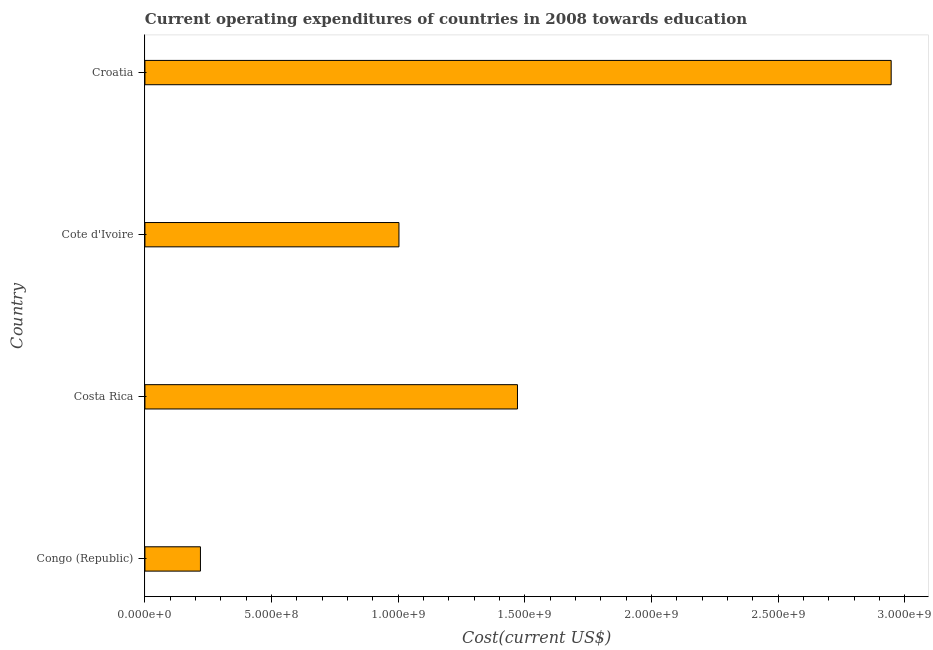Does the graph contain grids?
Offer a very short reply. No. What is the title of the graph?
Make the answer very short. Current operating expenditures of countries in 2008 towards education. What is the label or title of the X-axis?
Offer a terse response. Cost(current US$). What is the education expenditure in Croatia?
Your answer should be very brief. 2.95e+09. Across all countries, what is the maximum education expenditure?
Offer a very short reply. 2.95e+09. Across all countries, what is the minimum education expenditure?
Your answer should be very brief. 2.19e+08. In which country was the education expenditure maximum?
Provide a short and direct response. Croatia. In which country was the education expenditure minimum?
Keep it short and to the point. Congo (Republic). What is the sum of the education expenditure?
Offer a very short reply. 5.64e+09. What is the difference between the education expenditure in Congo (Republic) and Croatia?
Keep it short and to the point. -2.73e+09. What is the average education expenditure per country?
Keep it short and to the point. 1.41e+09. What is the median education expenditure?
Your answer should be compact. 1.24e+09. In how many countries, is the education expenditure greater than 500000000 US$?
Your response must be concise. 3. What is the ratio of the education expenditure in Congo (Republic) to that in Croatia?
Ensure brevity in your answer.  0.07. Is the difference between the education expenditure in Congo (Republic) and Croatia greater than the difference between any two countries?
Offer a very short reply. Yes. What is the difference between the highest and the second highest education expenditure?
Your answer should be very brief. 1.48e+09. What is the difference between the highest and the lowest education expenditure?
Offer a very short reply. 2.73e+09. How many countries are there in the graph?
Provide a succinct answer. 4. What is the difference between two consecutive major ticks on the X-axis?
Give a very brief answer. 5.00e+08. What is the Cost(current US$) of Congo (Republic)?
Keep it short and to the point. 2.19e+08. What is the Cost(current US$) in Costa Rica?
Provide a short and direct response. 1.47e+09. What is the Cost(current US$) in Cote d'Ivoire?
Your answer should be compact. 1.00e+09. What is the Cost(current US$) in Croatia?
Keep it short and to the point. 2.95e+09. What is the difference between the Cost(current US$) in Congo (Republic) and Costa Rica?
Ensure brevity in your answer.  -1.25e+09. What is the difference between the Cost(current US$) in Congo (Republic) and Cote d'Ivoire?
Make the answer very short. -7.84e+08. What is the difference between the Cost(current US$) in Congo (Republic) and Croatia?
Give a very brief answer. -2.73e+09. What is the difference between the Cost(current US$) in Costa Rica and Cote d'Ivoire?
Give a very brief answer. 4.68e+08. What is the difference between the Cost(current US$) in Costa Rica and Croatia?
Your answer should be very brief. -1.48e+09. What is the difference between the Cost(current US$) in Cote d'Ivoire and Croatia?
Your answer should be very brief. -1.94e+09. What is the ratio of the Cost(current US$) in Congo (Republic) to that in Costa Rica?
Provide a short and direct response. 0.15. What is the ratio of the Cost(current US$) in Congo (Republic) to that in Cote d'Ivoire?
Offer a terse response. 0.22. What is the ratio of the Cost(current US$) in Congo (Republic) to that in Croatia?
Offer a terse response. 0.07. What is the ratio of the Cost(current US$) in Costa Rica to that in Cote d'Ivoire?
Provide a short and direct response. 1.47. What is the ratio of the Cost(current US$) in Costa Rica to that in Croatia?
Make the answer very short. 0.5. What is the ratio of the Cost(current US$) in Cote d'Ivoire to that in Croatia?
Your answer should be compact. 0.34. 